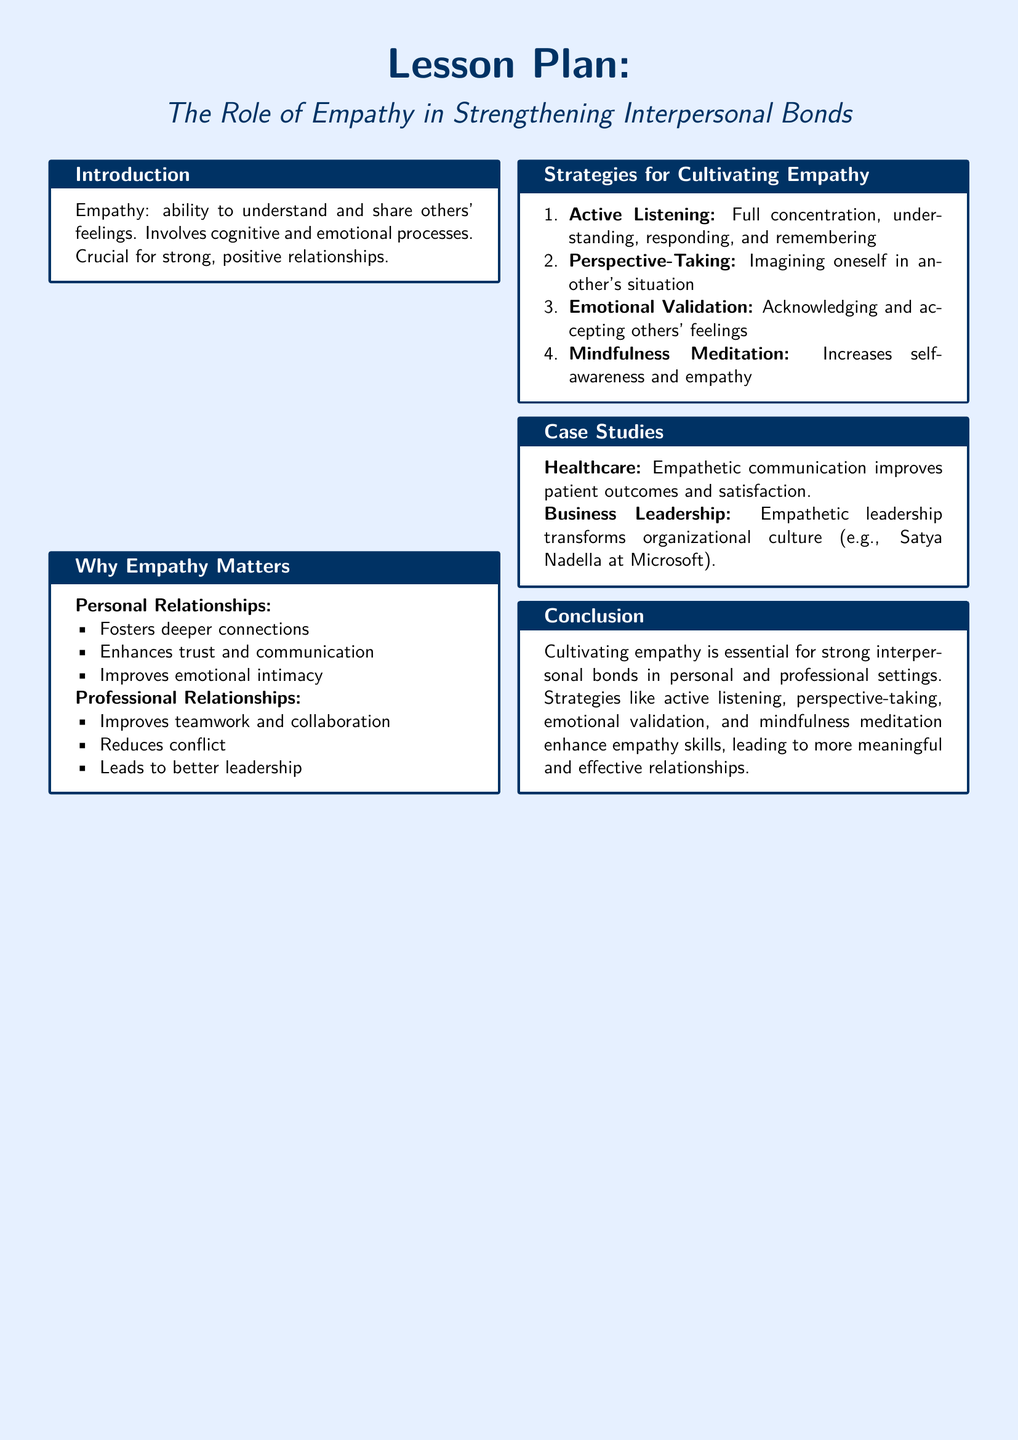What is the title of the lesson plan? The title of the lesson plan is presented prominently at the beginning of the document.
Answer: The Role of Empathy in Strengthening Interpersonal Bonds What color is used for the background of the document? The document specifies a light blue color for the background.
Answer: Light blue What is one of the reasons empathy matters in personal relationships? The document lists multiple reasons, and one of them is mentioned in the section under personal relationships.
Answer: Fosters deeper connections What is one strategy for cultivating empathy? The document enumerates several strategies, including this one found in the relevant section.
Answer: Active Listening What case study is mentioned in the healthcare section? The document provides a specific example illustrating the impact of empathy in healthcare.
Answer: Empathetic communication improves patient outcomes and satisfaction What organizational culture is transformed by empathetic leadership according to the case studies? The document draws on a specific example to show how empathy affects an organization.
Answer: Microsoft's culture How many strategies for cultivating empathy are listed? The document enumerates the strategies in a numbered format, indicating the total count.
Answer: Four 